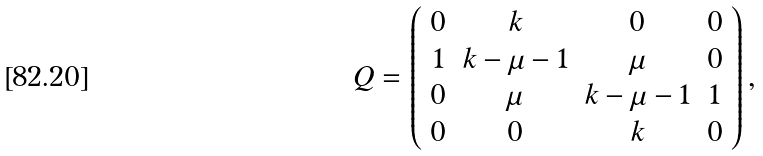<formula> <loc_0><loc_0><loc_500><loc_500>Q = \left ( \begin{array} { c c c c } 0 & k & 0 & 0 \\ 1 & k - \mu - 1 & \mu & 0 \\ 0 & \mu & k - \mu - 1 & 1 \\ 0 & 0 & k & 0 \\ \end{array} \right ) ,</formula> 